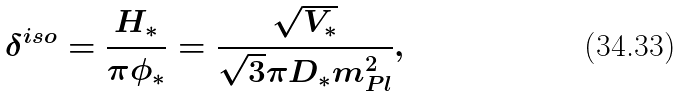Convert formula to latex. <formula><loc_0><loc_0><loc_500><loc_500>\delta ^ { i s o } = \frac { H _ { * } } { \pi \phi _ { * } } = \frac { \sqrt { V _ { * } } } { \sqrt { 3 } \pi D _ { * } m ^ { 2 } _ { P l } } ,</formula> 